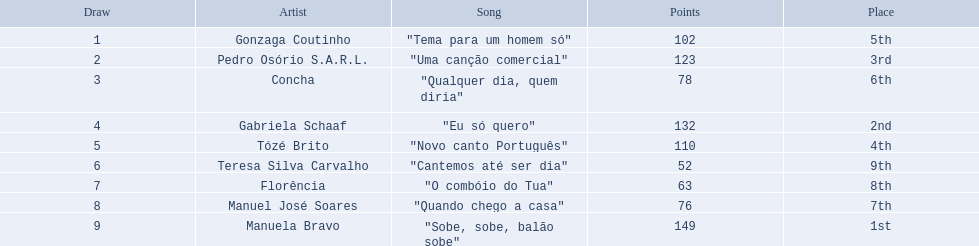Which musicians took part in the 1979 eurovision song contest? Gonzaga Coutinho, Pedro Osório S.A.R.L., Concha, Gabriela Schaaf, Tózé Brito, Teresa Silva Carvalho, Florência, Manuel José Soares, Manuela Bravo. From them, who sang "eu só quero"? Gabriela Schaaf. 